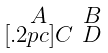<formula> <loc_0><loc_0><loc_500><loc_500>\begin{smallmatrix} A & B \\ [ . 2 p c ] C & D \end{smallmatrix}</formula> 